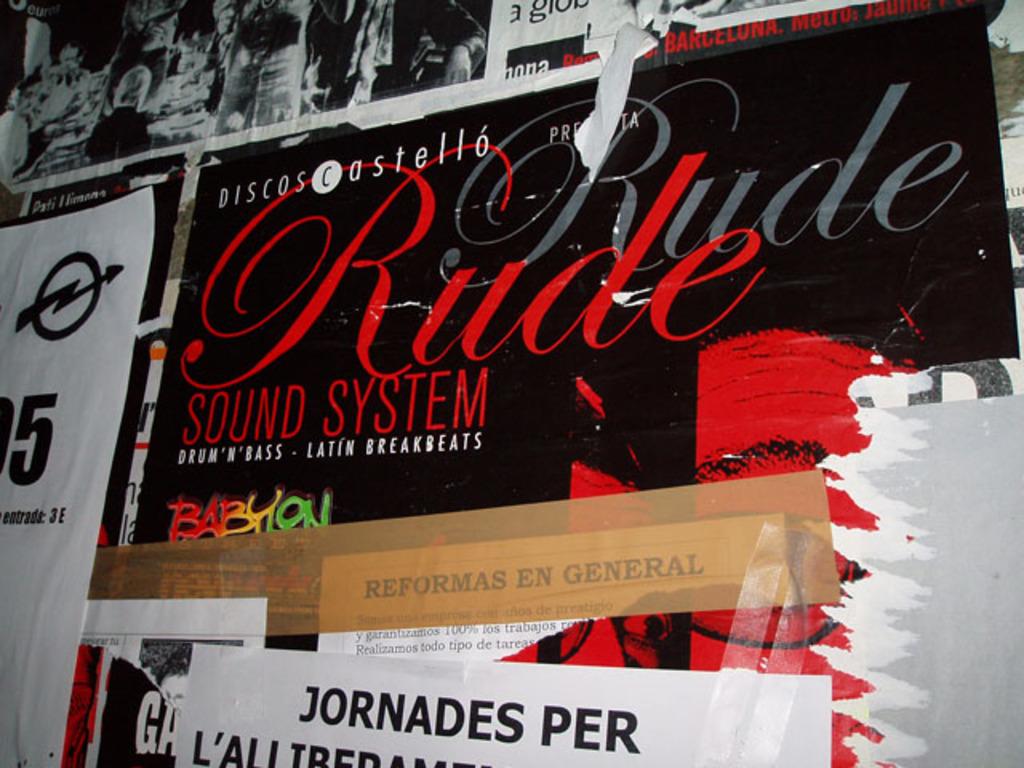What kind of sound system?
Give a very brief answer. Rude. What word  is in multi color?
Give a very brief answer. Babylon. 